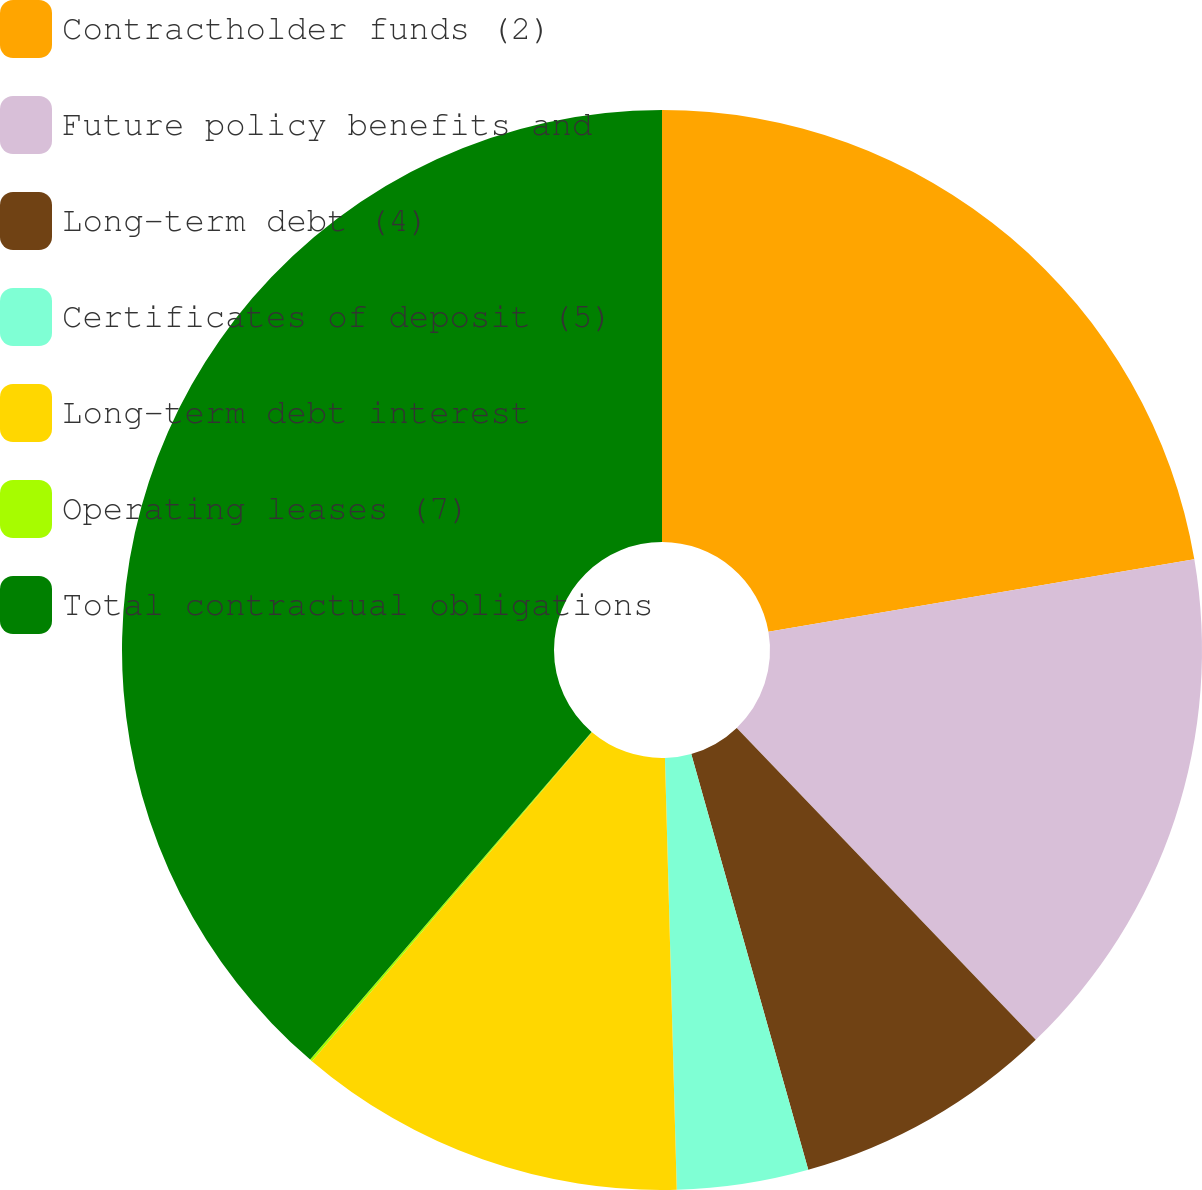Convert chart. <chart><loc_0><loc_0><loc_500><loc_500><pie_chart><fcel>Contractholder funds (2)<fcel>Future policy benefits and<fcel>Long-term debt (4)<fcel>Certificates of deposit (5)<fcel>Long-term debt interest<fcel>Operating leases (7)<fcel>Total contractual obligations<nl><fcel>22.31%<fcel>15.52%<fcel>7.8%<fcel>3.93%<fcel>11.66%<fcel>0.07%<fcel>38.7%<nl></chart> 